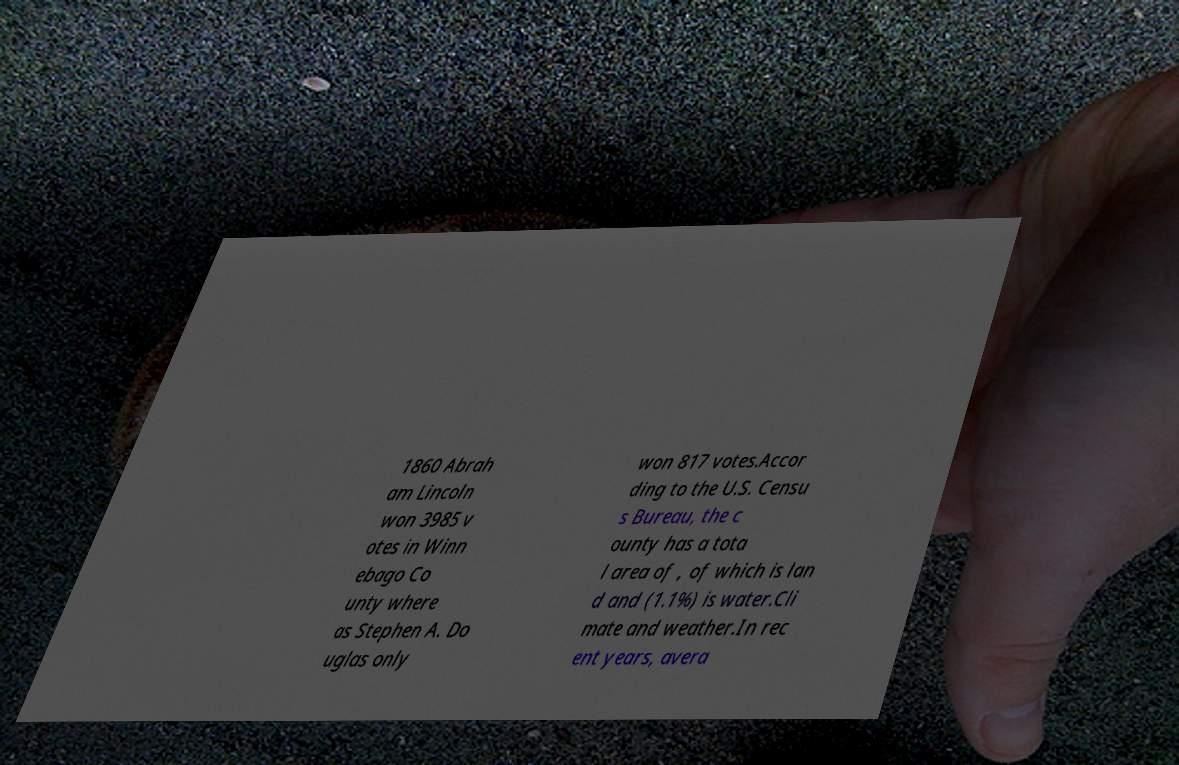Could you extract and type out the text from this image? 1860 Abrah am Lincoln won 3985 v otes in Winn ebago Co unty where as Stephen A. Do uglas only won 817 votes.Accor ding to the U.S. Censu s Bureau, the c ounty has a tota l area of , of which is lan d and (1.1%) is water.Cli mate and weather.In rec ent years, avera 